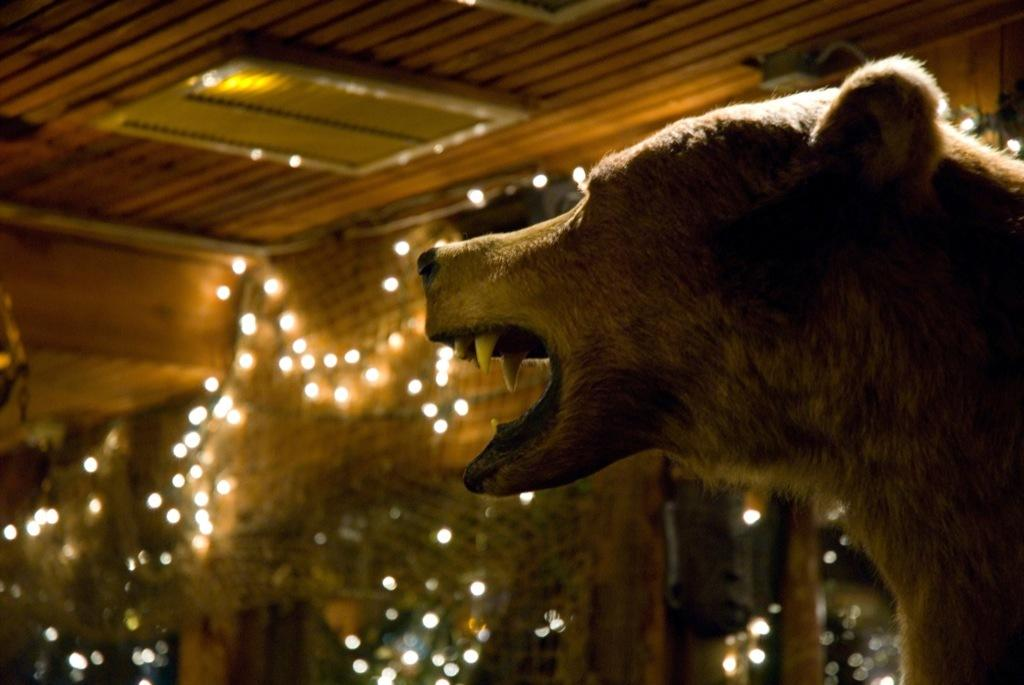What type of animal can be seen in the image? There is an animal in the image, but its specific type cannot be determined from the provided facts. What can be seen in the background of the image? There is a wall with a net and lights in the background of the image. What is visible at the top of the image? There is a ceiling visible at the top of the image. Where is the nest of the dinosaurs in the image? There are no dinosaurs or nests present in the image. What type of celery is being used as a prop in the image? There is no celery present in the image. 